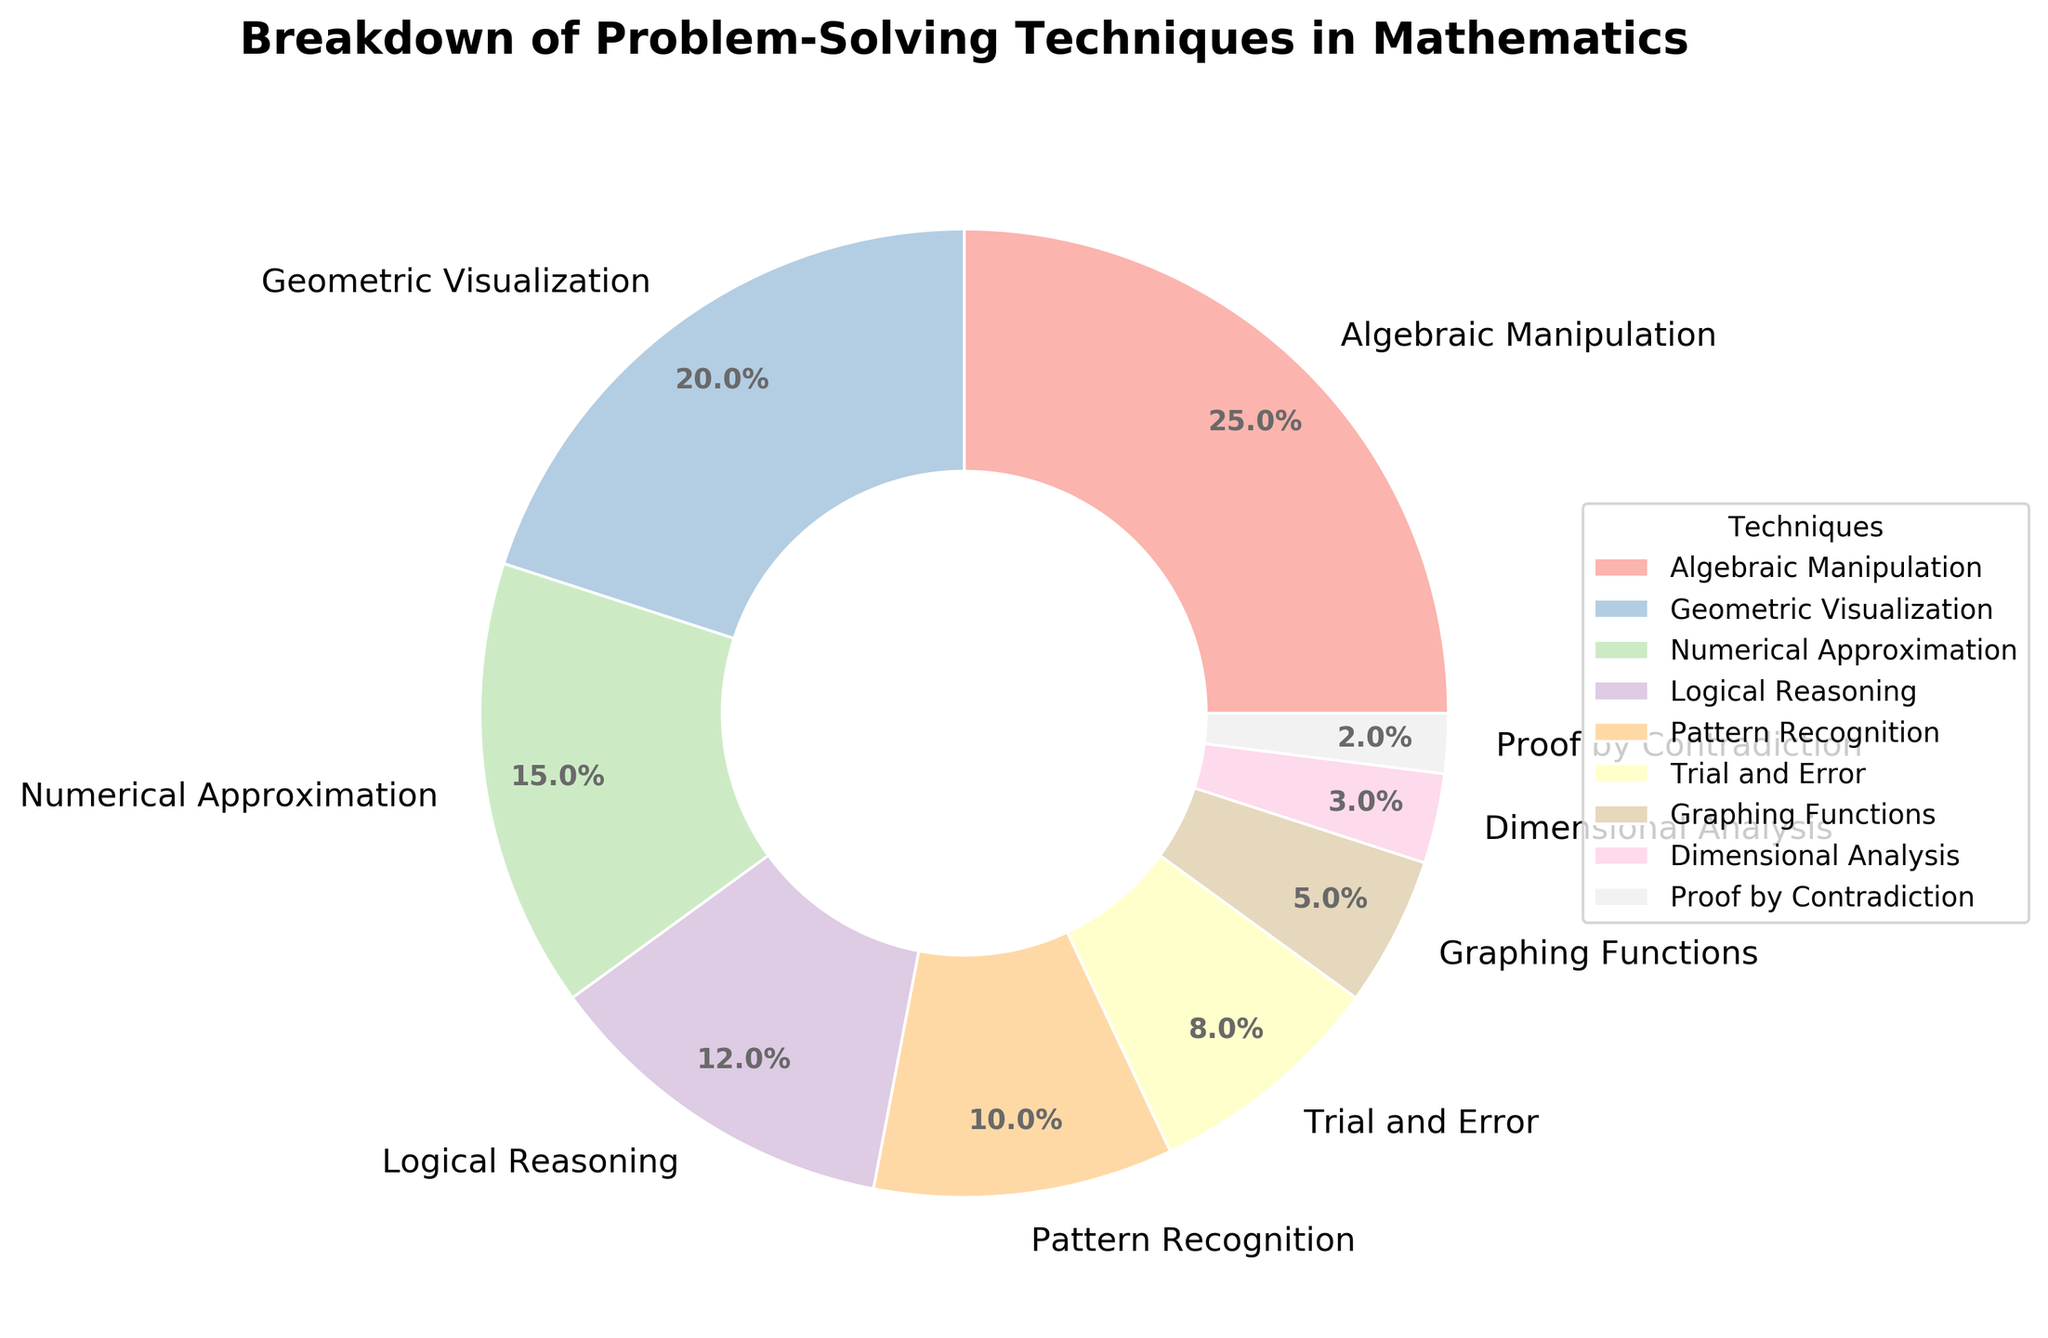What is the percentage of time spent on Algebraic Manipulation? The pie chart shows different problem-solving techniques with their respective percentages. According to the chart, Algebraic Manipulation accounts for 25% of the time spent.
Answer: 25% Which technique takes up the least amount of time? Examining the pie chart, we see that Proof by Contradiction has the smallest wedge, indicating it takes up the least amount of time at 2%.
Answer: Proof by Contradiction What is the total percentage of time spent on Numerical Approximation, Pattern Recognition, and Trial and Error combined? The percentages for Numerical Approximation, Pattern Recognition, and Trial and Error are 15%, 10%, and 8% respectively. Adding them gives 15% + 10% + 8% = 33%.
Answer: 33% How does the time spent on Geometric Visualization compare to the time spent on Graphing Functions? The percentage of time spent on Geometric Visualization is 20%, while the time spent on Graphing Functions is 5%. Therefore, Geometric Visualization has a larger percentage by 15%.
Answer: 15% more What is the difference in the percentages between the most utilized technique and the least utilized technique? The most utilized technique is Algebraic Manipulation at 25%, and the least utilized technique is Proof by Contradiction at 2%. The difference is 25% - 2% = 23%.
Answer: 23% What color is used to represent Logical Reasoning in the pie chart? The pie chart utilizes custom colors for each technique. Logical Reasoning, which takes up 12% of the chart, appears in a distinct color. To find the exact color, you need to visually inspect the chart and identify its corresponding segment.
Answer: (Visual inspection needed) Sum up the percentages of time spent on techniques involving geometric or spatial reasoning, i.e., Geometric Visualization and Graphing Functions. Geometric Visualization accounts for 20% and Graphing Functions for 5%. Summing these gives 20% + 5% = 25%.
Answer: 25% If you were to group Logical Reasoning and Pattern Recognition together, what would their combined percentage be, and where would this new group rank in terms of time spent? Logical Reasoning is 12% and Pattern Recognition is 10%. Combined, they make 12% + 10% = 22%. This new group would be the second-highest in time spent after Algebraic Manipulation (25%).
Answer: 22%, second-highest How much more time is devoted to Trial and Error than to Dimensional Analysis? Time spent on Trial and Error is 8%, while Dimensional Analysis is 3%. The difference is 8% - 3% = 5%.
Answer: 5% 